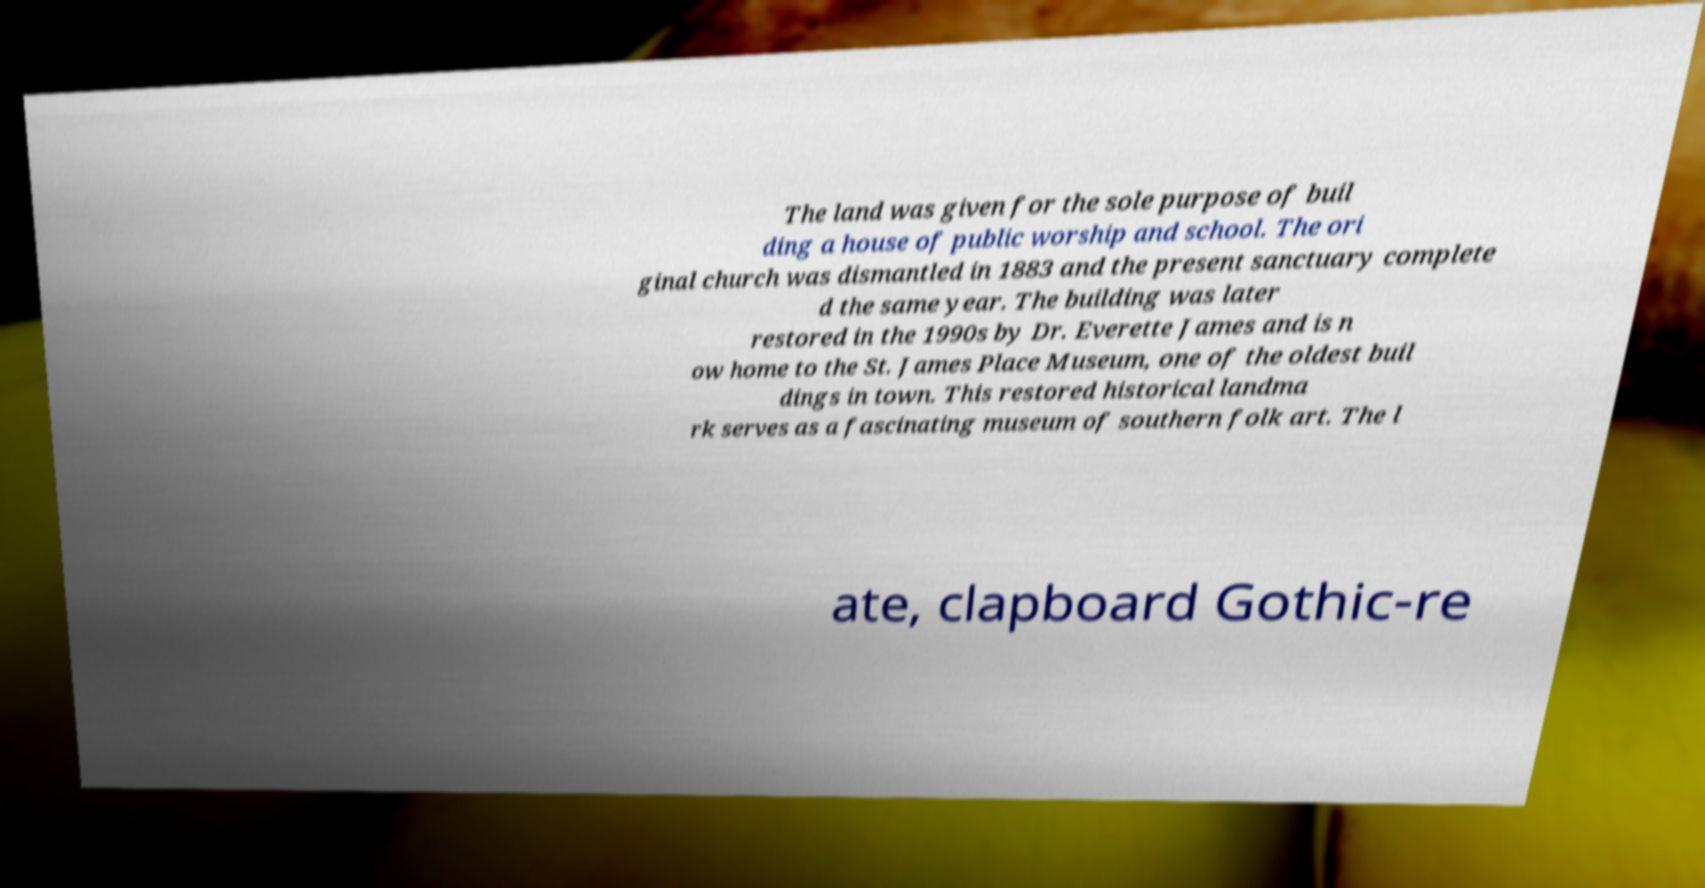Can you read and provide the text displayed in the image?This photo seems to have some interesting text. Can you extract and type it out for me? The land was given for the sole purpose of buil ding a house of public worship and school. The ori ginal church was dismantled in 1883 and the present sanctuary complete d the same year. The building was later restored in the 1990s by Dr. Everette James and is n ow home to the St. James Place Museum, one of the oldest buil dings in town. This restored historical landma rk serves as a fascinating museum of southern folk art. The l ate, clapboard Gothic-re 